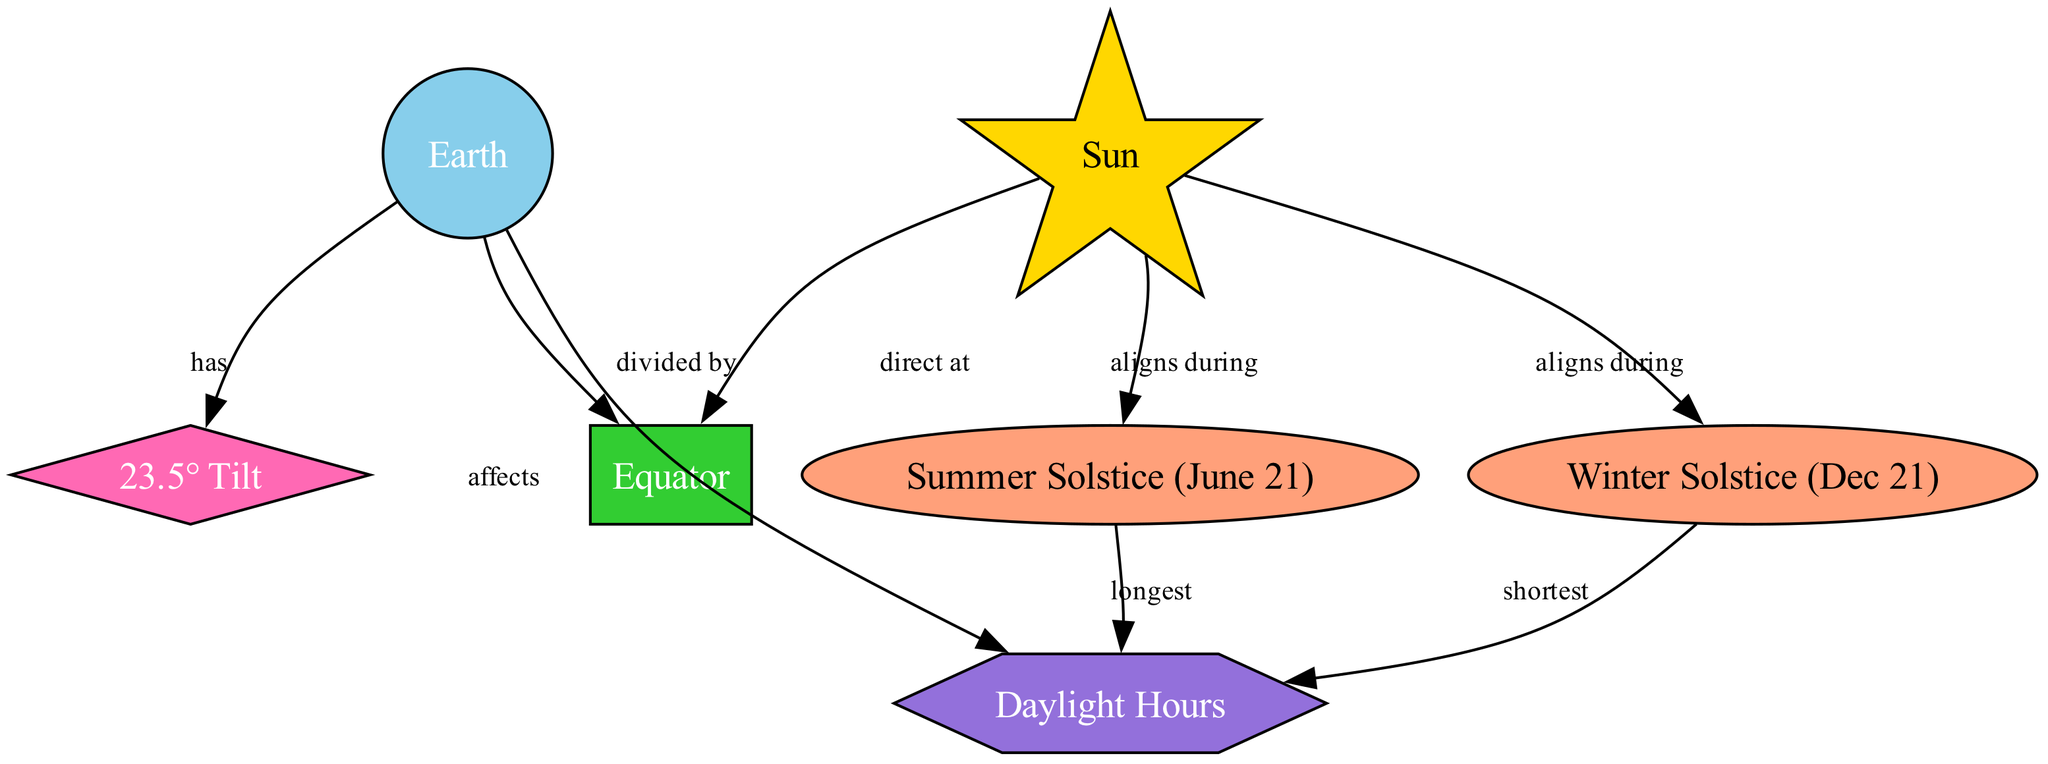What is the tilt angle of Earth? The diagram shows that Earth has a tilt of 23.5°, which is a specific detail noted in one of the nodes labeled "23.5° Tilt".
Answer: 23.5° How many events related to seasonal variations are depicted? In the diagram, there are two events labeled "Summer Solstice (June 21)" and "Winter Solstice (Dec 21)", indicating that the total count is 2 events.
Answer: 2 Which solstice is associated with the longest daylight hours? The diagram states that during the "Summer Solstice (June 21)", the "Daylight Hours" are described as the longest, establishing a clear relationship between this event and the daylight duration.
Answer: Summer Solstice (June 21) What effect does the Earth's tilt have on daylight hours? The diagram indicates that Earth's tilt directly affects "Daylight Hours," shown as an edge labeled "affects" between the nodes "Earth" and "Daylight Hours". This confirms the relationship.
Answer: affects During which solstice does the Sun align with Earth to produce the shortest daylight hours? According to the diagram, during the "Winter Solstice (Dec 21)", the Sun aligns with Earth leading to the "shortest" daylight hours, as stated in the relationship between the respective nodes.
Answer: Winter Solstice (Dec 21) What is the relationship between the Sun and the Equator? The diagram reveals that the "Sun" is described as "direct at" the "Equator", demonstrating a direct relationship where sunlight is aligned with the Equator.
Answer: direct at What kind of measurement is included in the diagram? The diagram includes "Daylight Hours" as a measurement type, which is highlighted as a distinct node with a specific label identifying it as a measurement category in the context of seasonal variations.
Answer: Daylight Hours How does the Sun align during the summer solstice? The alignment of the Sun during the "Summer Solstice (June 21)" is depicted in the diagram, specifically highlighting this event as a period when the Sun is positioned favorably for maximum daylight near this date.
Answer: aligns during 